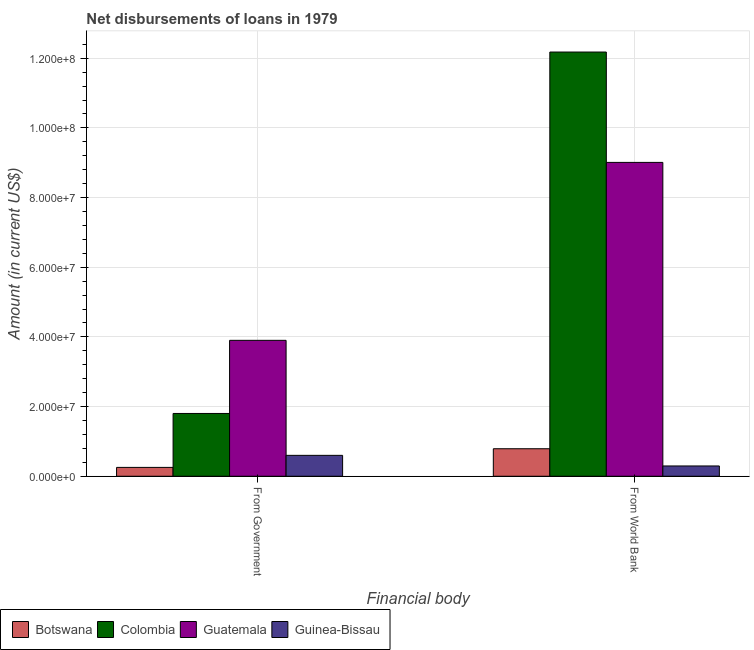How many different coloured bars are there?
Your response must be concise. 4. Are the number of bars per tick equal to the number of legend labels?
Offer a very short reply. Yes. Are the number of bars on each tick of the X-axis equal?
Offer a very short reply. Yes. What is the label of the 2nd group of bars from the left?
Your response must be concise. From World Bank. What is the net disbursements of loan from government in Guinea-Bissau?
Give a very brief answer. 6.00e+06. Across all countries, what is the maximum net disbursements of loan from government?
Your response must be concise. 3.90e+07. Across all countries, what is the minimum net disbursements of loan from government?
Offer a terse response. 2.54e+06. In which country was the net disbursements of loan from world bank maximum?
Make the answer very short. Colombia. In which country was the net disbursements of loan from world bank minimum?
Provide a short and direct response. Guinea-Bissau. What is the total net disbursements of loan from government in the graph?
Provide a short and direct response. 6.56e+07. What is the difference between the net disbursements of loan from government in Botswana and that in Guatemala?
Ensure brevity in your answer.  -3.65e+07. What is the difference between the net disbursements of loan from world bank in Guatemala and the net disbursements of loan from government in Botswana?
Your response must be concise. 8.76e+07. What is the average net disbursements of loan from world bank per country?
Offer a terse response. 5.57e+07. What is the difference between the net disbursements of loan from world bank and net disbursements of loan from government in Colombia?
Offer a terse response. 1.04e+08. What is the ratio of the net disbursements of loan from world bank in Colombia to that in Guatemala?
Provide a succinct answer. 1.35. In how many countries, is the net disbursements of loan from world bank greater than the average net disbursements of loan from world bank taken over all countries?
Provide a succinct answer. 2. What does the 3rd bar from the left in From Government represents?
Provide a short and direct response. Guatemala. What does the 1st bar from the right in From Government represents?
Offer a terse response. Guinea-Bissau. How many bars are there?
Keep it short and to the point. 8. Are all the bars in the graph horizontal?
Provide a succinct answer. No. How many legend labels are there?
Offer a terse response. 4. How are the legend labels stacked?
Give a very brief answer. Horizontal. What is the title of the graph?
Keep it short and to the point. Net disbursements of loans in 1979. What is the label or title of the X-axis?
Make the answer very short. Financial body. What is the Amount (in current US$) in Botswana in From Government?
Your response must be concise. 2.54e+06. What is the Amount (in current US$) of Colombia in From Government?
Give a very brief answer. 1.80e+07. What is the Amount (in current US$) in Guatemala in From Government?
Your answer should be compact. 3.90e+07. What is the Amount (in current US$) in Botswana in From World Bank?
Your answer should be compact. 7.90e+06. What is the Amount (in current US$) in Colombia in From World Bank?
Give a very brief answer. 1.22e+08. What is the Amount (in current US$) in Guatemala in From World Bank?
Make the answer very short. 9.01e+07. What is the Amount (in current US$) of Guinea-Bissau in From World Bank?
Provide a succinct answer. 2.95e+06. Across all Financial body, what is the maximum Amount (in current US$) in Botswana?
Ensure brevity in your answer.  7.90e+06. Across all Financial body, what is the maximum Amount (in current US$) in Colombia?
Your answer should be very brief. 1.22e+08. Across all Financial body, what is the maximum Amount (in current US$) in Guatemala?
Offer a terse response. 9.01e+07. Across all Financial body, what is the minimum Amount (in current US$) of Botswana?
Your response must be concise. 2.54e+06. Across all Financial body, what is the minimum Amount (in current US$) of Colombia?
Give a very brief answer. 1.80e+07. Across all Financial body, what is the minimum Amount (in current US$) of Guatemala?
Make the answer very short. 3.90e+07. Across all Financial body, what is the minimum Amount (in current US$) in Guinea-Bissau?
Provide a short and direct response. 2.95e+06. What is the total Amount (in current US$) in Botswana in the graph?
Provide a short and direct response. 1.04e+07. What is the total Amount (in current US$) in Colombia in the graph?
Your response must be concise. 1.40e+08. What is the total Amount (in current US$) in Guatemala in the graph?
Offer a terse response. 1.29e+08. What is the total Amount (in current US$) of Guinea-Bissau in the graph?
Provide a short and direct response. 8.95e+06. What is the difference between the Amount (in current US$) in Botswana in From Government and that in From World Bank?
Your response must be concise. -5.36e+06. What is the difference between the Amount (in current US$) of Colombia in From Government and that in From World Bank?
Keep it short and to the point. -1.04e+08. What is the difference between the Amount (in current US$) of Guatemala in From Government and that in From World Bank?
Your answer should be very brief. -5.11e+07. What is the difference between the Amount (in current US$) in Guinea-Bissau in From Government and that in From World Bank?
Give a very brief answer. 3.05e+06. What is the difference between the Amount (in current US$) of Botswana in From Government and the Amount (in current US$) of Colombia in From World Bank?
Offer a very short reply. -1.19e+08. What is the difference between the Amount (in current US$) of Botswana in From Government and the Amount (in current US$) of Guatemala in From World Bank?
Ensure brevity in your answer.  -8.76e+07. What is the difference between the Amount (in current US$) of Botswana in From Government and the Amount (in current US$) of Guinea-Bissau in From World Bank?
Ensure brevity in your answer.  -4.13e+05. What is the difference between the Amount (in current US$) in Colombia in From Government and the Amount (in current US$) in Guatemala in From World Bank?
Make the answer very short. -7.21e+07. What is the difference between the Amount (in current US$) in Colombia in From Government and the Amount (in current US$) in Guinea-Bissau in From World Bank?
Give a very brief answer. 1.51e+07. What is the difference between the Amount (in current US$) of Guatemala in From Government and the Amount (in current US$) of Guinea-Bissau in From World Bank?
Your answer should be very brief. 3.61e+07. What is the average Amount (in current US$) of Botswana per Financial body?
Make the answer very short. 5.22e+06. What is the average Amount (in current US$) in Colombia per Financial body?
Give a very brief answer. 6.99e+07. What is the average Amount (in current US$) of Guatemala per Financial body?
Provide a short and direct response. 6.46e+07. What is the average Amount (in current US$) in Guinea-Bissau per Financial body?
Offer a terse response. 4.48e+06. What is the difference between the Amount (in current US$) in Botswana and Amount (in current US$) in Colombia in From Government?
Keep it short and to the point. -1.55e+07. What is the difference between the Amount (in current US$) in Botswana and Amount (in current US$) in Guatemala in From Government?
Make the answer very short. -3.65e+07. What is the difference between the Amount (in current US$) in Botswana and Amount (in current US$) in Guinea-Bissau in From Government?
Provide a short and direct response. -3.46e+06. What is the difference between the Amount (in current US$) of Colombia and Amount (in current US$) of Guatemala in From Government?
Your answer should be compact. -2.10e+07. What is the difference between the Amount (in current US$) of Colombia and Amount (in current US$) of Guinea-Bissau in From Government?
Provide a short and direct response. 1.20e+07. What is the difference between the Amount (in current US$) of Guatemala and Amount (in current US$) of Guinea-Bissau in From Government?
Ensure brevity in your answer.  3.30e+07. What is the difference between the Amount (in current US$) in Botswana and Amount (in current US$) in Colombia in From World Bank?
Your response must be concise. -1.14e+08. What is the difference between the Amount (in current US$) of Botswana and Amount (in current US$) of Guatemala in From World Bank?
Offer a very short reply. -8.22e+07. What is the difference between the Amount (in current US$) of Botswana and Amount (in current US$) of Guinea-Bissau in From World Bank?
Make the answer very short. 4.95e+06. What is the difference between the Amount (in current US$) in Colombia and Amount (in current US$) in Guatemala in From World Bank?
Your answer should be very brief. 3.17e+07. What is the difference between the Amount (in current US$) of Colombia and Amount (in current US$) of Guinea-Bissau in From World Bank?
Your response must be concise. 1.19e+08. What is the difference between the Amount (in current US$) in Guatemala and Amount (in current US$) in Guinea-Bissau in From World Bank?
Offer a terse response. 8.72e+07. What is the ratio of the Amount (in current US$) of Botswana in From Government to that in From World Bank?
Give a very brief answer. 0.32. What is the ratio of the Amount (in current US$) in Colombia in From Government to that in From World Bank?
Ensure brevity in your answer.  0.15. What is the ratio of the Amount (in current US$) of Guatemala in From Government to that in From World Bank?
Ensure brevity in your answer.  0.43. What is the ratio of the Amount (in current US$) of Guinea-Bissau in From Government to that in From World Bank?
Your answer should be compact. 2.03. What is the difference between the highest and the second highest Amount (in current US$) in Botswana?
Provide a succinct answer. 5.36e+06. What is the difference between the highest and the second highest Amount (in current US$) in Colombia?
Keep it short and to the point. 1.04e+08. What is the difference between the highest and the second highest Amount (in current US$) in Guatemala?
Ensure brevity in your answer.  5.11e+07. What is the difference between the highest and the second highest Amount (in current US$) in Guinea-Bissau?
Offer a terse response. 3.05e+06. What is the difference between the highest and the lowest Amount (in current US$) of Botswana?
Your answer should be compact. 5.36e+06. What is the difference between the highest and the lowest Amount (in current US$) in Colombia?
Provide a succinct answer. 1.04e+08. What is the difference between the highest and the lowest Amount (in current US$) of Guatemala?
Provide a short and direct response. 5.11e+07. What is the difference between the highest and the lowest Amount (in current US$) in Guinea-Bissau?
Offer a terse response. 3.05e+06. 